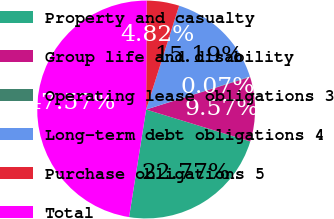Convert chart. <chart><loc_0><loc_0><loc_500><loc_500><pie_chart><fcel>Property and casualty<fcel>Group life and disability<fcel>Operating lease obligations 3<fcel>Long-term debt obligations 4<fcel>Purchase obligations 5<fcel>Total<nl><fcel>22.77%<fcel>9.57%<fcel>0.07%<fcel>15.19%<fcel>4.82%<fcel>47.56%<nl></chart> 